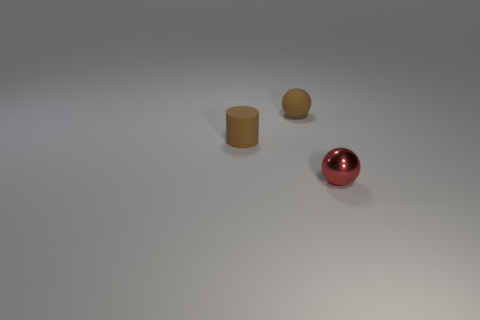Is there anything in the image that indicates its size or scale? The image does not contain typical indicators of size or scale such as familiar objects or a background with depth perspective. The three objects are floating with no reference points, leaving their actual size and the scale of the scene ambiguous. 